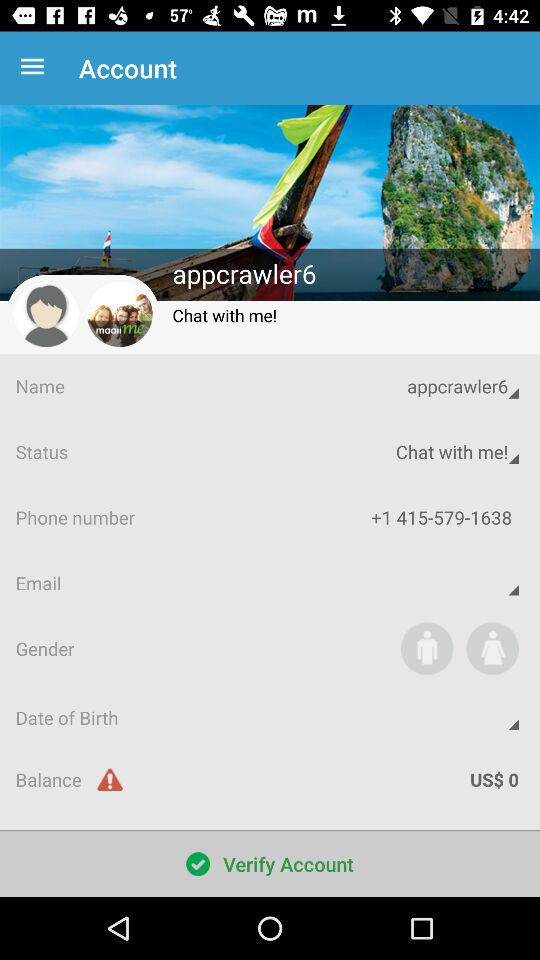What is the phone number? The phone number is +1 415-579-1638. 